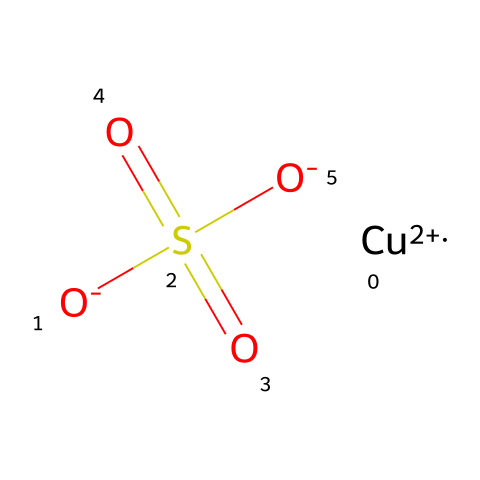What is the central metal atom in copper sulfate? The chemical structure shows the presence of a copper ion represented by Cu+2. This indicates that copper is the central metal atom in the molecule.
Answer: copper How many oxygen atoms are present in copper sulfate? The chemical structure indicates three oxygen atoms (from the three O atoms in the sulfate group and one attached to copper), resulting in a total of four oxygen atoms in the expression of copper sulfate.
Answer: four What is the overall charge of copper sulfate? The charges from the copper ion (Cu+2) and the two negatively charged sulfate oxygen atoms (-2 from O-) sum up to zero, indicating that the compound is neutral.
Answer: neutral What type of bonding is primarily present in copper sulfate? The chemical structure demonstrates ionic bonding between the copper ion (Cu+2) and the sulfate ion (SO4-2), resulting in ionic interactions due to the charges.
Answer: ionic How many sulfur atoms are in copper sulfate? Analyzing the structure reveals there is one sulfur atom present within the sulfate group (SO4), which is a part of the chemical structure of copper sulfate.
Answer: one 